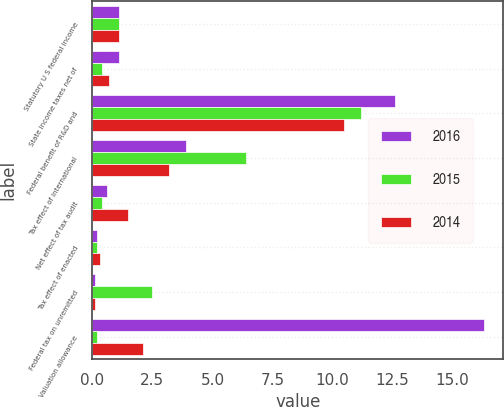<chart> <loc_0><loc_0><loc_500><loc_500><stacked_bar_chart><ecel><fcel>Statutory U S federal income<fcel>State income taxes net of<fcel>Federal benefit of R&D and<fcel>Tax effect of international<fcel>Net effect of tax audit<fcel>Tax effect of enacted<fcel>Federal tax on unremitted<fcel>Valuation allowance<nl><fcel>2016<fcel>1.1<fcel>1.1<fcel>12.6<fcel>3.9<fcel>0.6<fcel>0.2<fcel>0.1<fcel>16.3<nl><fcel>2015<fcel>1.1<fcel>0.4<fcel>11.2<fcel>6.4<fcel>0.4<fcel>0.2<fcel>2.5<fcel>0.2<nl><fcel>2014<fcel>1.1<fcel>0.7<fcel>10.5<fcel>3.2<fcel>1.5<fcel>0.3<fcel>0.1<fcel>2.1<nl></chart> 